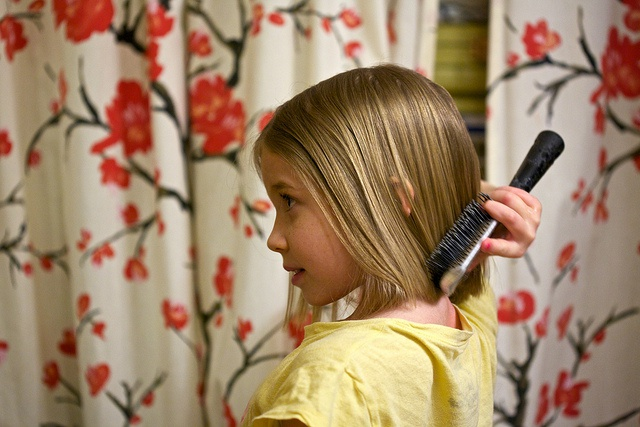Describe the objects in this image and their specific colors. I can see people in tan, khaki, maroon, and olive tones in this image. 